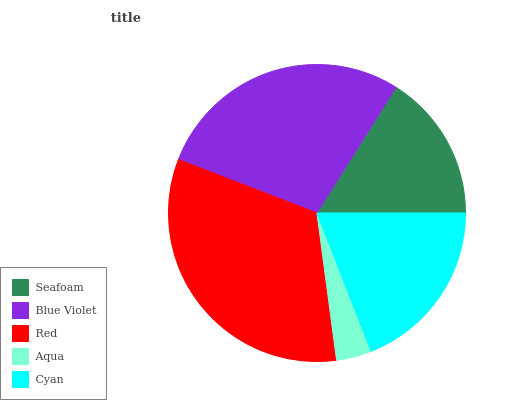Is Aqua the minimum?
Answer yes or no. Yes. Is Red the maximum?
Answer yes or no. Yes. Is Blue Violet the minimum?
Answer yes or no. No. Is Blue Violet the maximum?
Answer yes or no. No. Is Blue Violet greater than Seafoam?
Answer yes or no. Yes. Is Seafoam less than Blue Violet?
Answer yes or no. Yes. Is Seafoam greater than Blue Violet?
Answer yes or no. No. Is Blue Violet less than Seafoam?
Answer yes or no. No. Is Cyan the high median?
Answer yes or no. Yes. Is Cyan the low median?
Answer yes or no. Yes. Is Red the high median?
Answer yes or no. No. Is Red the low median?
Answer yes or no. No. 